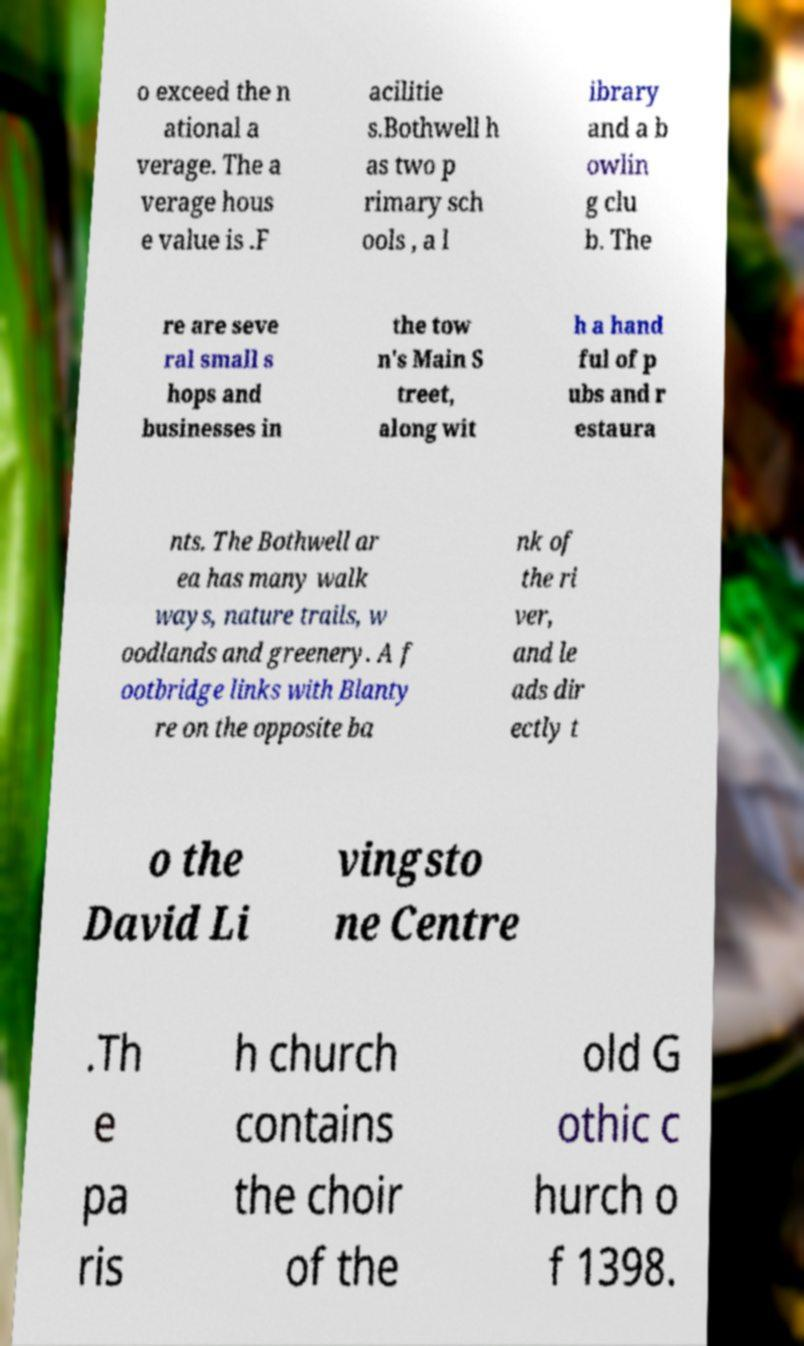What messages or text are displayed in this image? I need them in a readable, typed format. o exceed the n ational a verage. The a verage hous e value is .F acilitie s.Bothwell h as two p rimary sch ools , a l ibrary and a b owlin g clu b. The re are seve ral small s hops and businesses in the tow n's Main S treet, along wit h a hand ful of p ubs and r estaura nts. The Bothwell ar ea has many walk ways, nature trails, w oodlands and greenery. A f ootbridge links with Blanty re on the opposite ba nk of the ri ver, and le ads dir ectly t o the David Li vingsto ne Centre .Th e pa ris h church contains the choir of the old G othic c hurch o f 1398. 